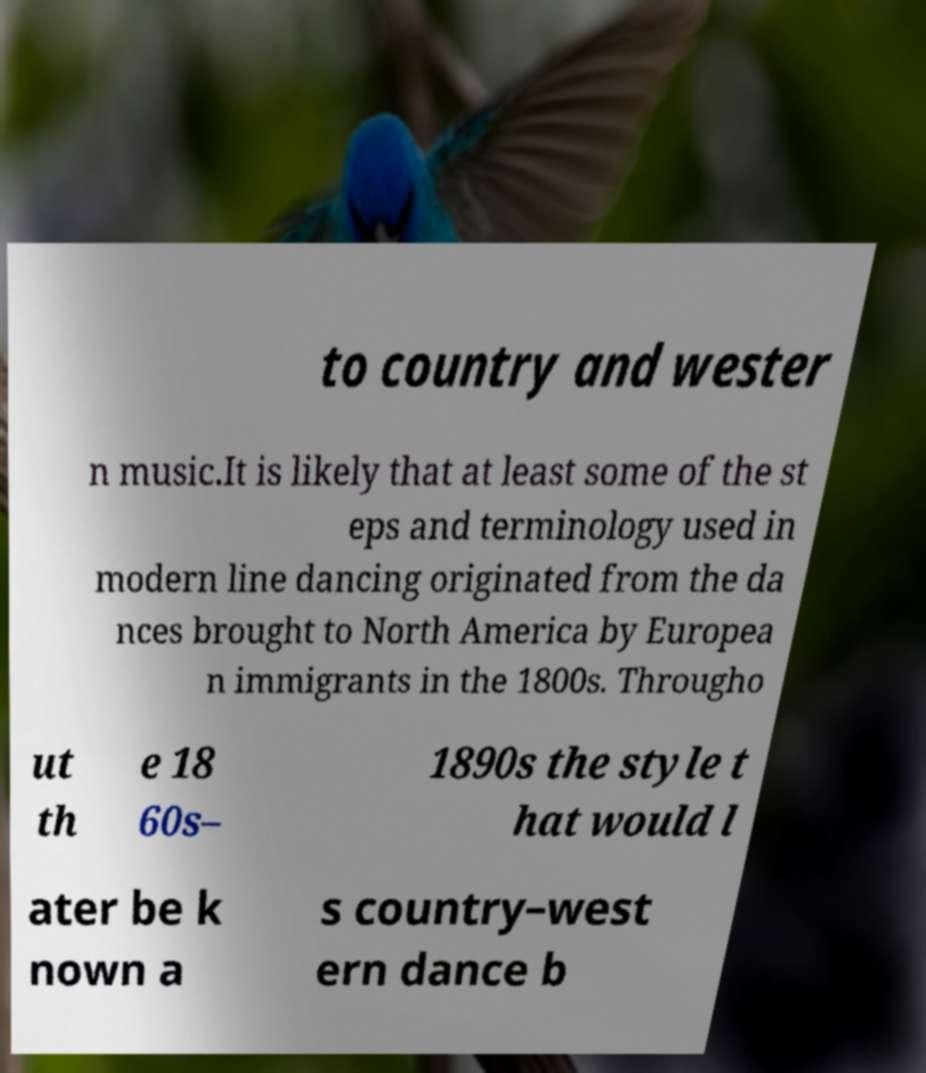Can you read and provide the text displayed in the image?This photo seems to have some interesting text. Can you extract and type it out for me? to country and wester n music.It is likely that at least some of the st eps and terminology used in modern line dancing originated from the da nces brought to North America by Europea n immigrants in the 1800s. Througho ut th e 18 60s– 1890s the style t hat would l ater be k nown a s country–west ern dance b 